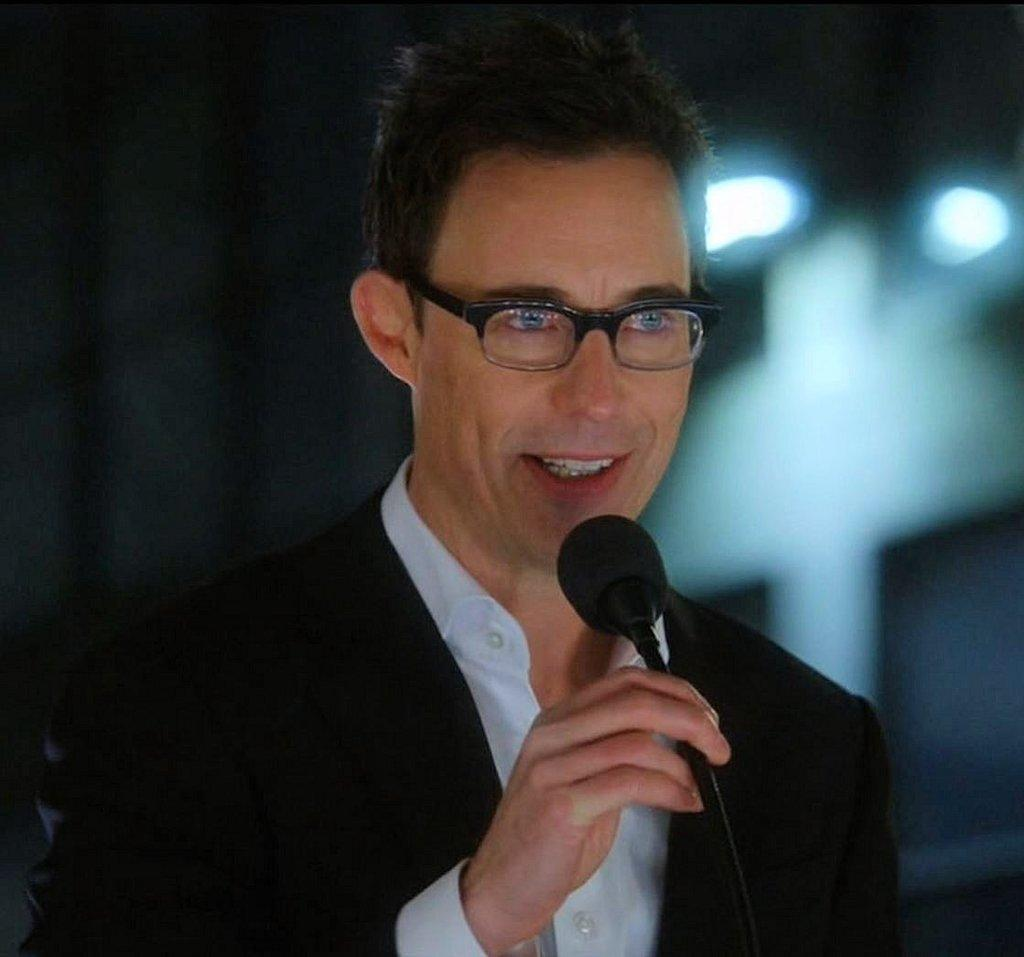Who is the main subject in the image? There is a man in the image. What is the man holding in the image? The man is holding a microphone. Can you describe any accessories the man is wearing? The man is wearing glasses. How would you describe the background of the image? The background of the image is blurry. What type of sign can be seen in the image? There is no sign present in the image. Can you describe the leaves on the tree in the image? There is no tree or leaves present in the image. 